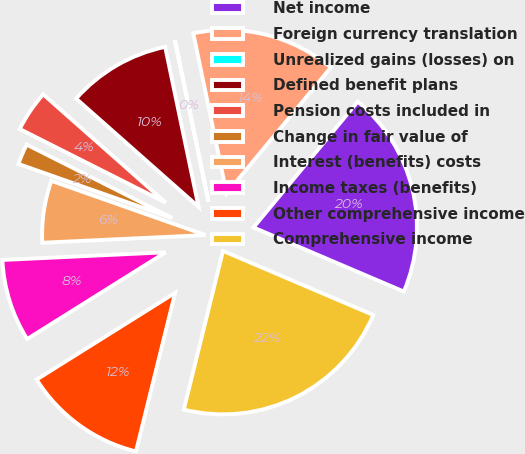Convert chart to OTSL. <chart><loc_0><loc_0><loc_500><loc_500><pie_chart><fcel>Net income<fcel>Foreign currency translation<fcel>Unrealized gains (losses) on<fcel>Defined benefit plans<fcel>Pension costs included in<fcel>Change in fair value of<fcel>Interest (benefits) costs<fcel>Income taxes (benefits)<fcel>Other comprehensive income<fcel>Comprehensive income<nl><fcel>20.4%<fcel>14.28%<fcel>0.01%<fcel>10.2%<fcel>4.09%<fcel>2.05%<fcel>6.13%<fcel>8.16%<fcel>12.24%<fcel>22.44%<nl></chart> 